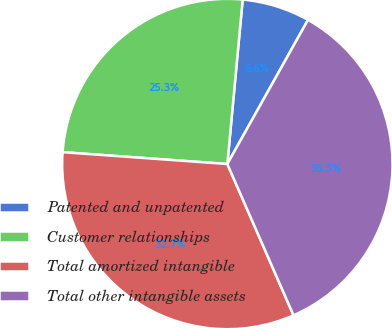Convert chart to OTSL. <chart><loc_0><loc_0><loc_500><loc_500><pie_chart><fcel>Patented and unpatented<fcel>Customer relationships<fcel>Total amortized intangible<fcel>Total other intangible assets<nl><fcel>6.64%<fcel>25.34%<fcel>32.71%<fcel>35.32%<nl></chart> 